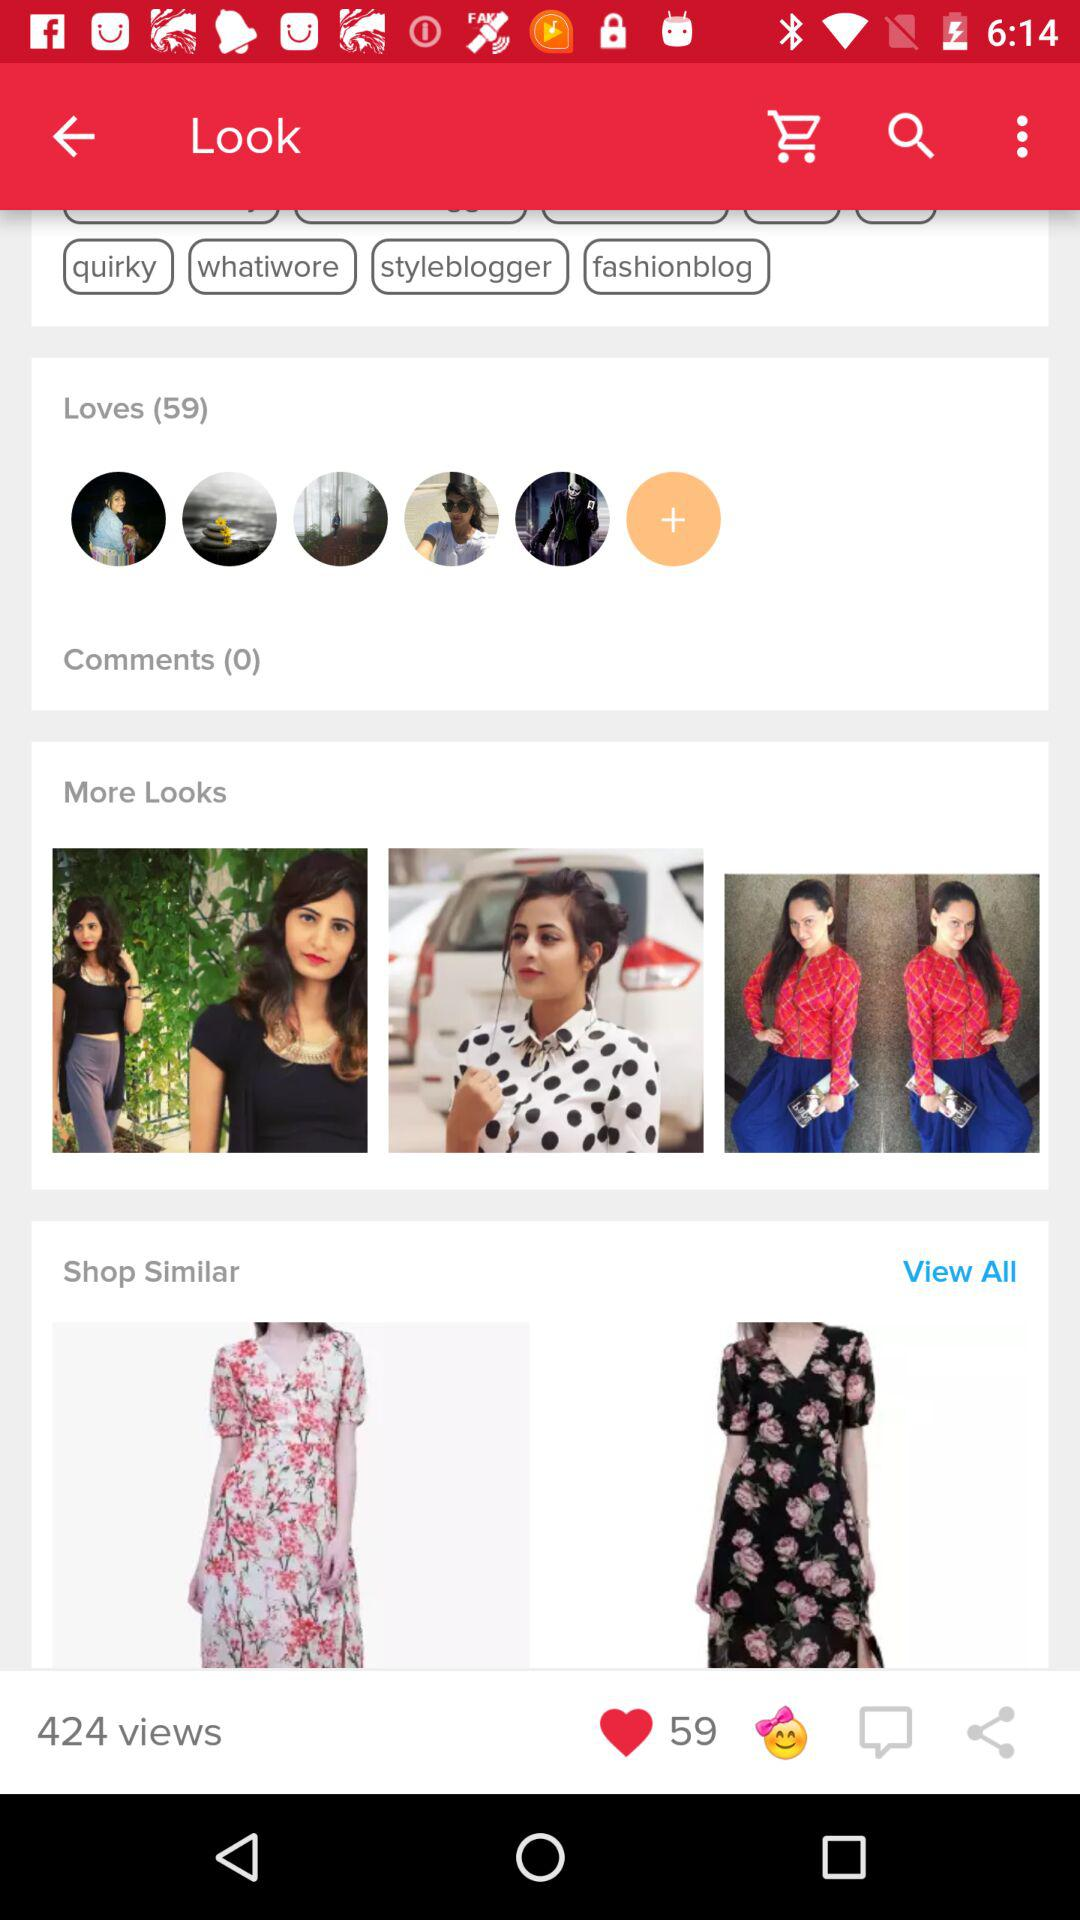What's the total number of comments? The total number of comments is 0. 